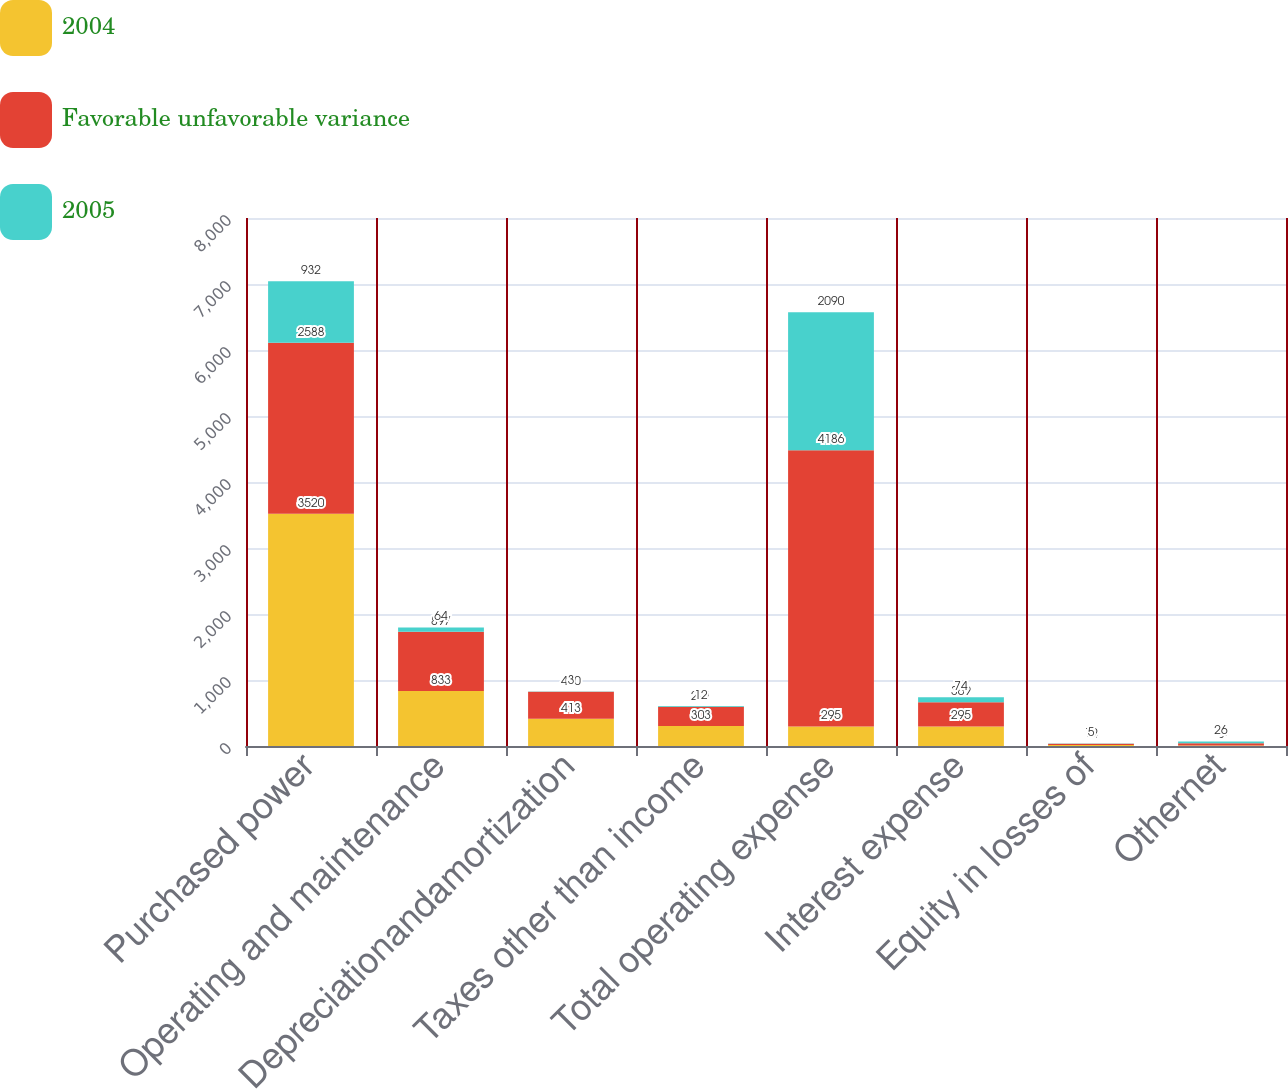Convert chart. <chart><loc_0><loc_0><loc_500><loc_500><stacked_bar_chart><ecel><fcel>Purchased power<fcel>Operating and maintenance<fcel>Depreciationandamortization<fcel>Taxes other than income<fcel>Total operating expense<fcel>Interest expense<fcel>Equity in losses of<fcel>Othernet<nl><fcel>2004<fcel>3520<fcel>833<fcel>413<fcel>303<fcel>295<fcel>295<fcel>14<fcel>8<nl><fcel>Favorable unfavorable variance<fcel>2588<fcel>897<fcel>410<fcel>291<fcel>4186<fcel>369<fcel>19<fcel>34<nl><fcel>2005<fcel>932<fcel>64<fcel>3<fcel>12<fcel>2090<fcel>74<fcel>5<fcel>26<nl></chart> 